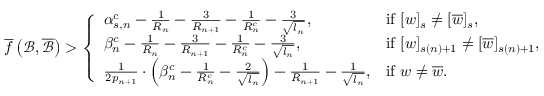<formula> <loc_0><loc_0><loc_500><loc_500>\overline { f } \left ( \mathcal { B } , \overline { { \mathcal { B } } } \right ) > \left \{ \begin{array} { l l } { \alpha _ { s , n } ^ { c } - \frac { 1 } { R _ { n } } - \frac { 3 } { R _ { n + 1 } } - \frac { 1 } { R _ { n } ^ { c } } - \frac { 3 } { \sqrt { l _ { n } } } , } & { i f [ w ] _ { s } \neq [ \overline { w } ] _ { s } , } \\ { \beta _ { n } ^ { c } - \frac { 1 } { R _ { n } } - \frac { 3 } { R _ { n + 1 } } - \frac { 1 } { R _ { n } ^ { c } } - \frac { 3 } { \sqrt { l _ { n } } } , } & { i f [ w ] _ { s ( n ) + 1 } \neq [ \overline { w } ] _ { s ( n ) + 1 } , } \\ { \frac { 1 } { 2 p _ { n + 1 } } \cdot \left ( \beta _ { n } ^ { c } - \frac { 1 } { R _ { n } ^ { c } } - \frac { 2 } { \sqrt { l _ { n } } } \right ) - \frac { 1 } { R _ { n + 1 } } - \frac { 1 } { \sqrt { l _ { n } } } , } & { i f w \neq \overline { w } . } \end{array}</formula> 